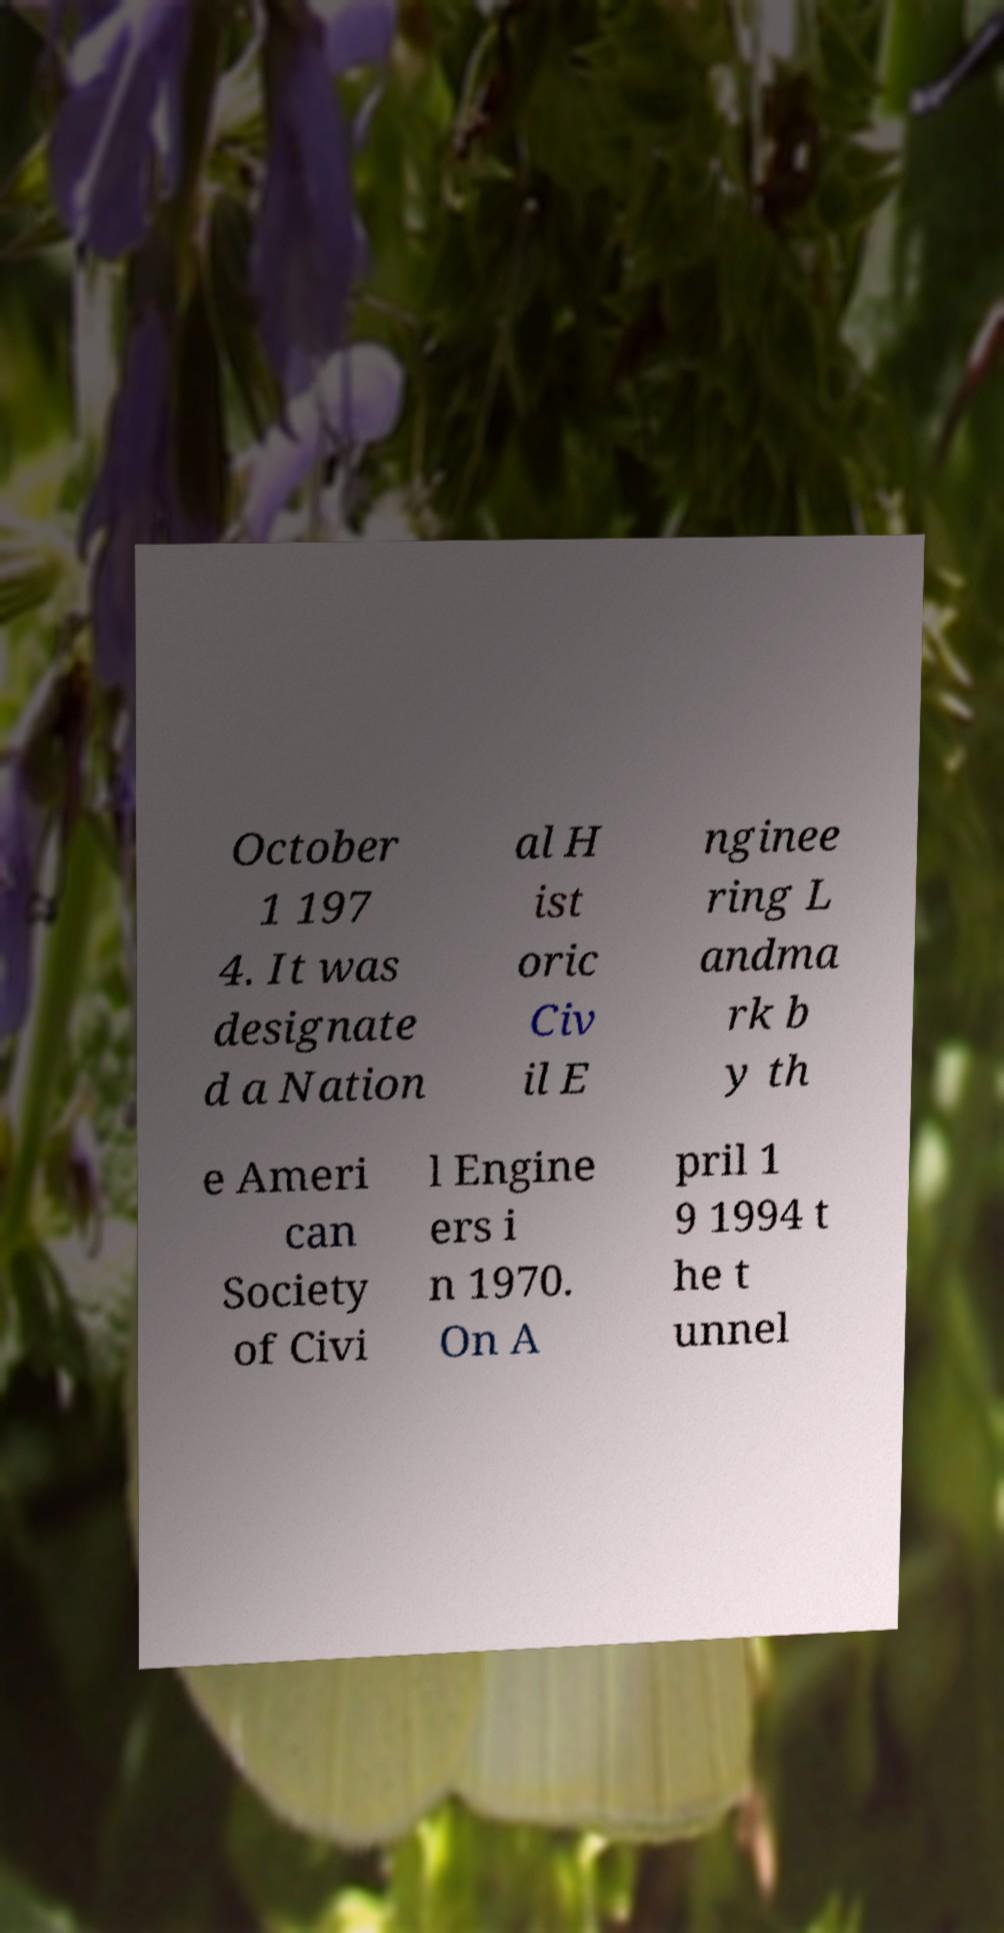Could you assist in decoding the text presented in this image and type it out clearly? October 1 197 4. It was designate d a Nation al H ist oric Civ il E nginee ring L andma rk b y th e Ameri can Society of Civi l Engine ers i n 1970. On A pril 1 9 1994 t he t unnel 